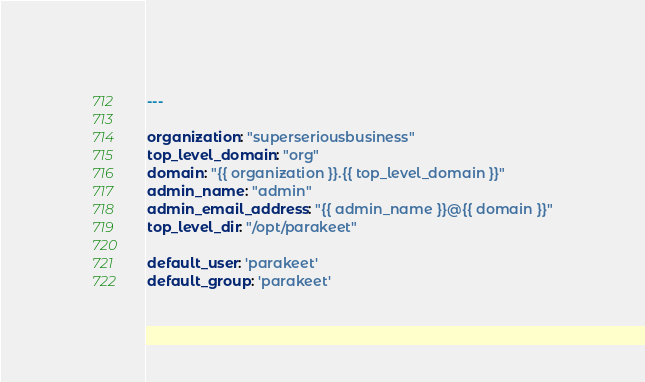<code> <loc_0><loc_0><loc_500><loc_500><_YAML_>---

organization: "superseriousbusiness"
top_level_domain: "org"
domain: "{{ organization }}.{{ top_level_domain }}"
admin_name: "admin"
admin_email_address: "{{ admin_name }}@{{ domain }}"
top_level_dir: "/opt/parakeet"

default_user: 'parakeet'
default_group: 'parakeet'
</code> 